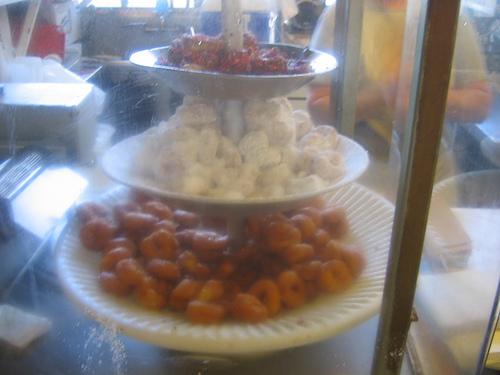How many tiers on the serving dish?
Concise answer only. 3. What is on the bottom dish?
Keep it brief. Fruit. Is this in a bakery?
Quick response, please. Yes. 